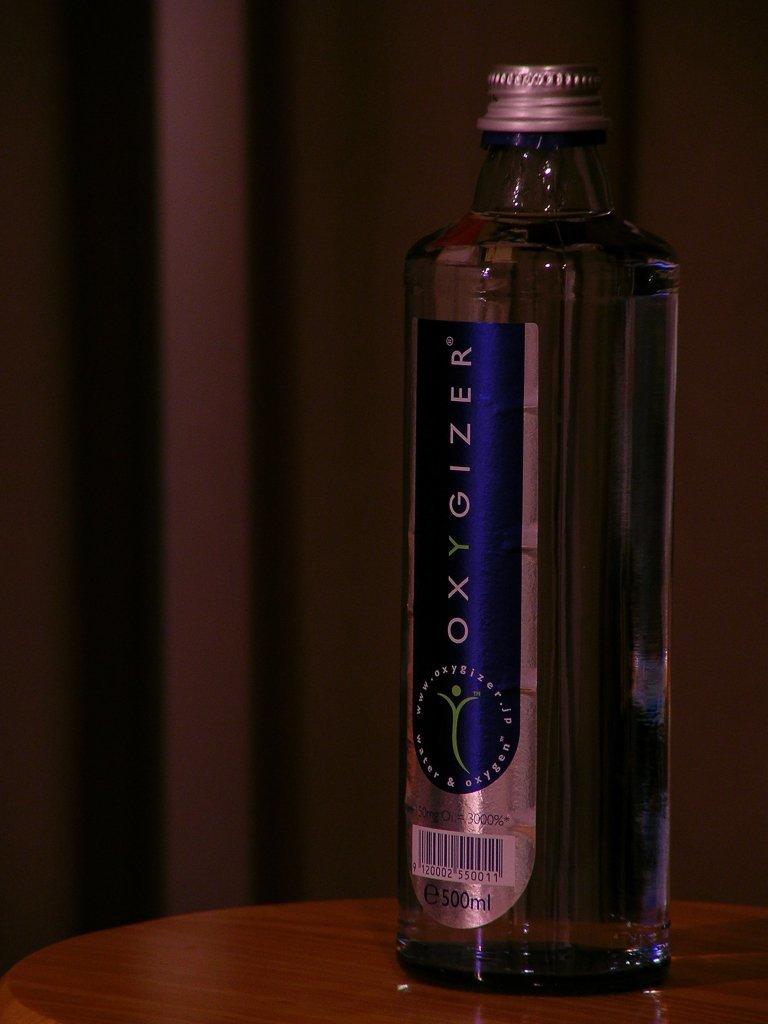What is the name of the beverage?
Your answer should be compact. Oxygizer. 